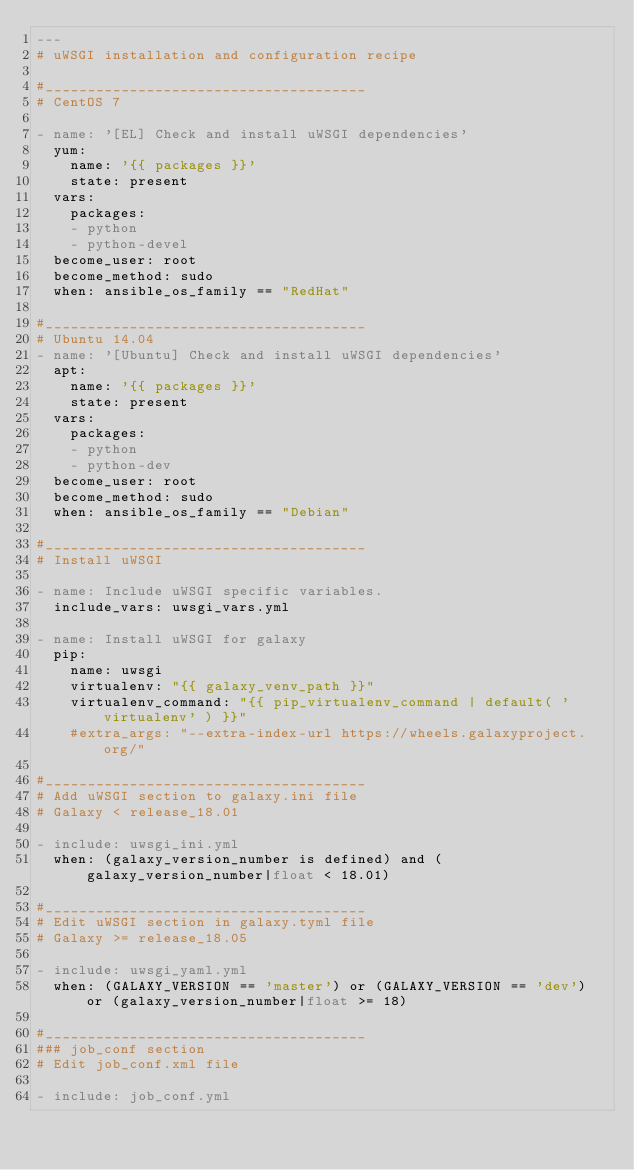<code> <loc_0><loc_0><loc_500><loc_500><_YAML_>---
# uWSGI installation and configuration recipe

#______________________________________
# CentOS 7

- name: '[EL] Check and install uWSGI dependencies'
  yum:
    name: '{{ packages }}'
    state: present
  vars:
    packages:
    - python
    - python-devel
  become_user: root
  become_method: sudo
  when: ansible_os_family == "RedHat"

#______________________________________
# Ubuntu 14.04
- name: '[Ubuntu] Check and install uWSGI dependencies'
  apt:
    name: '{{ packages }}'
    state: present
  vars:
    packages:
    - python
    - python-dev
  become_user: root
  become_method: sudo
  when: ansible_os_family == "Debian"

#______________________________________
# Install uWSGI

- name: Include uWSGI specific variables.
  include_vars: uwsgi_vars.yml

- name: Install uWSGI for galaxy
  pip:
    name: uwsgi
    virtualenv: "{{ galaxy_venv_path }}"
    virtualenv_command: "{{ pip_virtualenv_command | default( 'virtualenv' ) }}"
    #extra_args: "--extra-index-url https://wheels.galaxyproject.org/"

#______________________________________
# Add uWSGI section to galaxy.ini file
# Galaxy < release_18.01

- include: uwsgi_ini.yml
  when: (galaxy_version_number is defined) and (galaxy_version_number|float < 18.01)

#______________________________________
# Edit uWSGI section in galaxy.tyml file
# Galaxy >= release_18.05

- include: uwsgi_yaml.yml
  when: (GALAXY_VERSION == 'master') or (GALAXY_VERSION == 'dev') or (galaxy_version_number|float >= 18)

#______________________________________
### job_conf section
# Edit job_conf.xml file

- include: job_conf.yml
</code> 